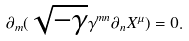Convert formula to latex. <formula><loc_0><loc_0><loc_500><loc_500>\partial _ { m } ( \sqrt { - \gamma } \gamma ^ { m n } \partial _ { n } X ^ { \mu } ) = 0 .</formula> 